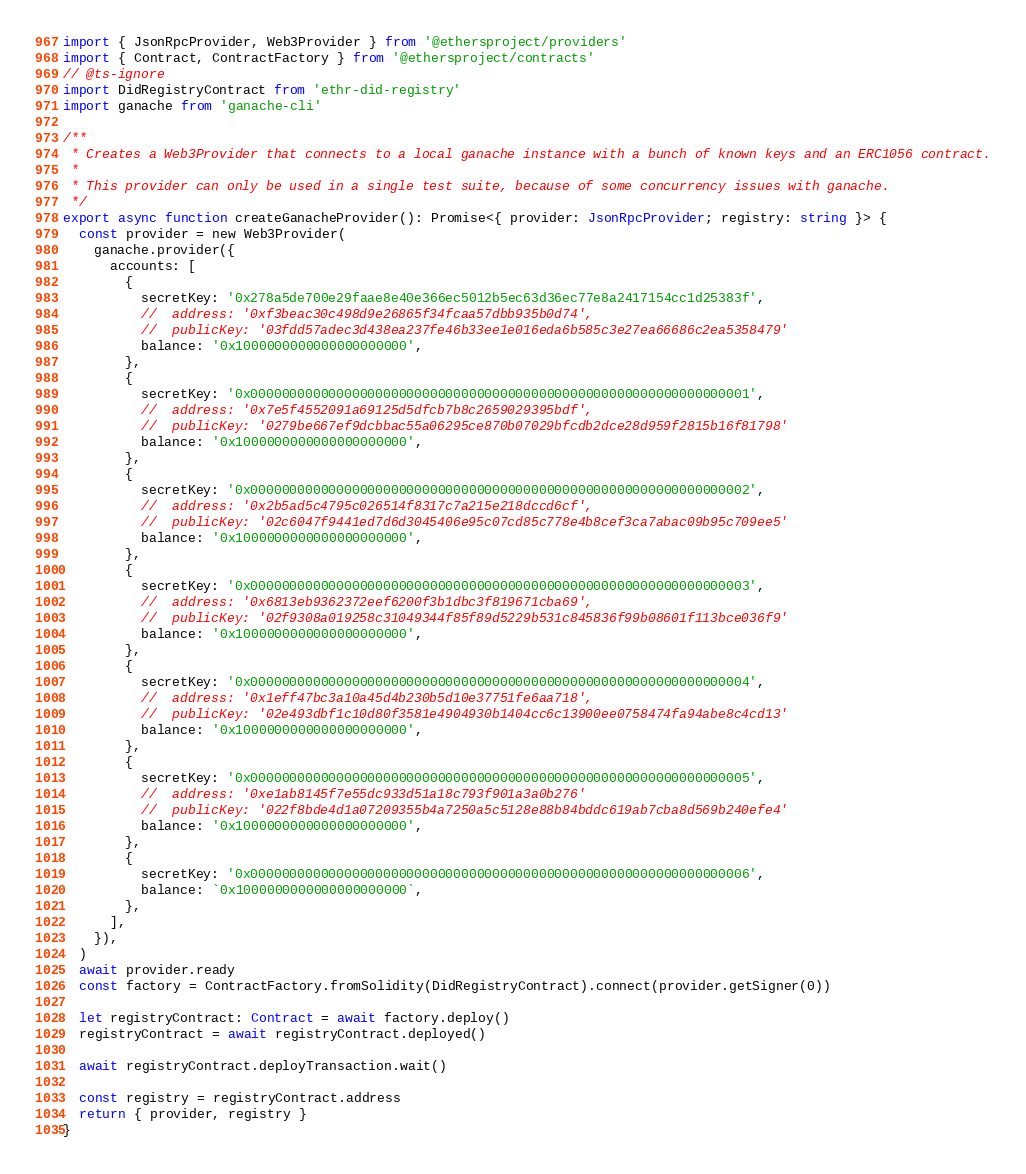Convert code to text. <code><loc_0><loc_0><loc_500><loc_500><_TypeScript_>import { JsonRpcProvider, Web3Provider } from '@ethersproject/providers'
import { Contract, ContractFactory } from '@ethersproject/contracts'
// @ts-ignore
import DidRegistryContract from 'ethr-did-registry'
import ganache from 'ganache-cli'

/**
 * Creates a Web3Provider that connects to a local ganache instance with a bunch of known keys and an ERC1056 contract.
 *
 * This provider can only be used in a single test suite, because of some concurrency issues with ganache.
 */
export async function createGanacheProvider(): Promise<{ provider: JsonRpcProvider; registry: string }> {
  const provider = new Web3Provider(
    ganache.provider({
      accounts: [
        {
          secretKey: '0x278a5de700e29faae8e40e366ec5012b5ec63d36ec77e8a2417154cc1d25383f',
          //  address: '0xf3beac30c498d9e26865f34fcaa57dbb935b0d74',
          //  publicKey: '03fdd57adec3d438ea237fe46b33ee1e016eda6b585c3e27ea66686c2ea5358479'
          balance: '0x1000000000000000000000',
        },
        {
          secretKey: '0x0000000000000000000000000000000000000000000000000000000000000001',
          //  address: '0x7e5f4552091a69125d5dfcb7b8c2659029395bdf',
          //  publicKey: '0279be667ef9dcbbac55a06295ce870b07029bfcdb2dce28d959f2815b16f81798'
          balance: '0x1000000000000000000000',
        },
        {
          secretKey: '0x0000000000000000000000000000000000000000000000000000000000000002',
          //  address: '0x2b5ad5c4795c026514f8317c7a215e218dccd6cf',
          //  publicKey: '02c6047f9441ed7d6d3045406e95c07cd85c778e4b8cef3ca7abac09b95c709ee5'
          balance: '0x1000000000000000000000',
        },
        {
          secretKey: '0x0000000000000000000000000000000000000000000000000000000000000003',
          //  address: '0x6813eb9362372eef6200f3b1dbc3f819671cba69',
          //  publicKey: '02f9308a019258c31049344f85f89d5229b531c845836f99b08601f113bce036f9'
          balance: '0x1000000000000000000000',
        },
        {
          secretKey: '0x0000000000000000000000000000000000000000000000000000000000000004',
          //  address: '0x1eff47bc3a10a45d4b230b5d10e37751fe6aa718',
          //  publicKey: '02e493dbf1c10d80f3581e4904930b1404cc6c13900ee0758474fa94abe8c4cd13'
          balance: '0x1000000000000000000000',
        },
        {
          secretKey: '0x0000000000000000000000000000000000000000000000000000000000000005',
          //  address: '0xe1ab8145f7e55dc933d51a18c793f901a3a0b276'
          //  publicKey: '022f8bde4d1a07209355b4a7250a5c5128e88b84bddc619ab7cba8d569b240efe4'
          balance: '0x1000000000000000000000',
        },
        {
          secretKey: '0x0000000000000000000000000000000000000000000000000000000000000006',
          balance: `0x1000000000000000000000`,
        },
      ],
    }),
  )
  await provider.ready
  const factory = ContractFactory.fromSolidity(DidRegistryContract).connect(provider.getSigner(0))

  let registryContract: Contract = await factory.deploy()
  registryContract = await registryContract.deployed()

  await registryContract.deployTransaction.wait()

  const registry = registryContract.address
  return { provider, registry }
}
</code> 